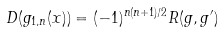Convert formula to latex. <formula><loc_0><loc_0><loc_500><loc_500>D ( g _ { 1 , n } ( x ) ) = ( - 1 ) ^ { n ( n + 1 ) / 2 } R ( g , g ^ { \prime } )</formula> 